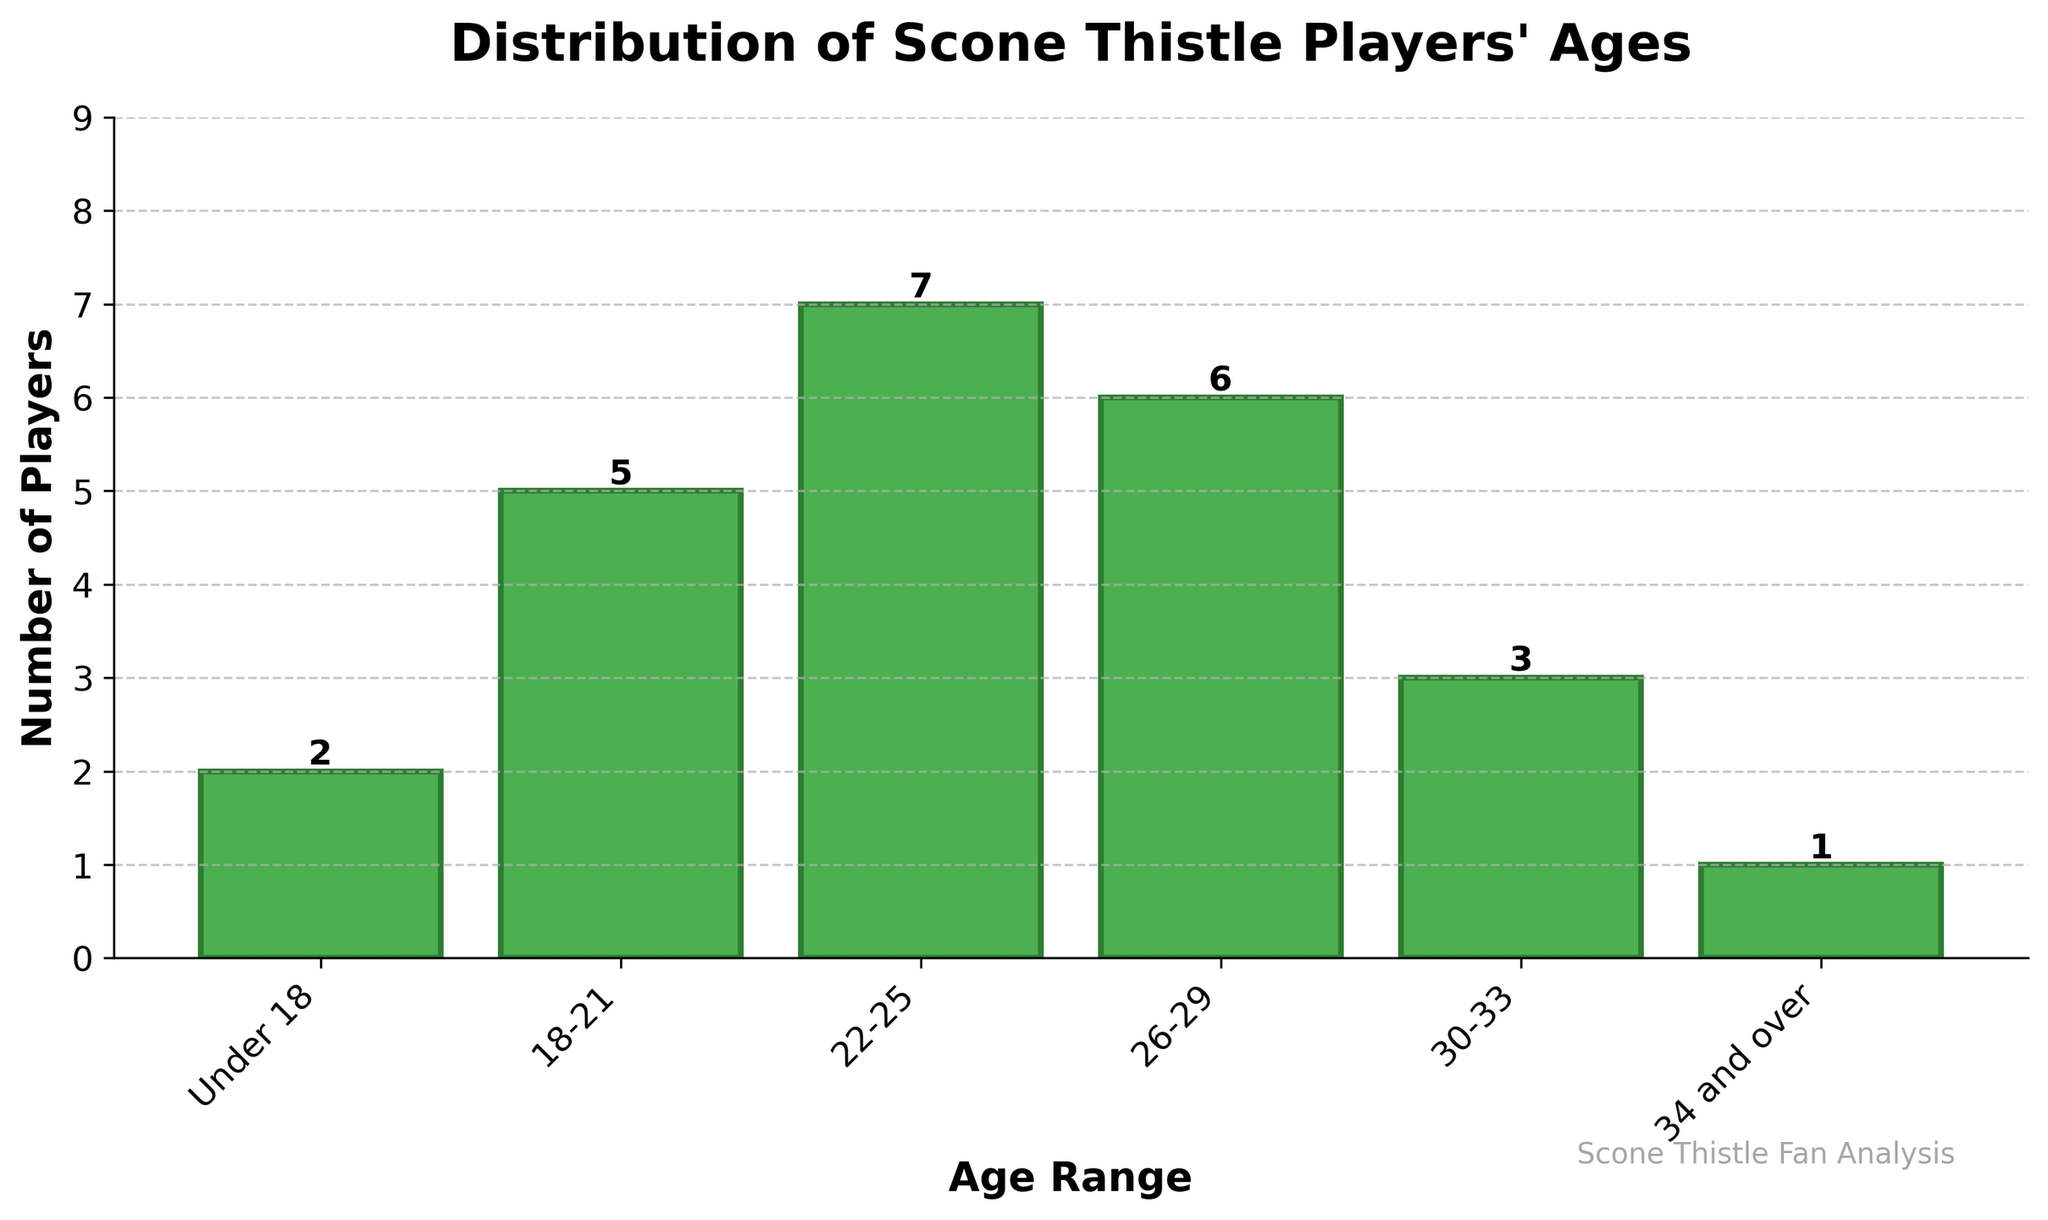What age range has the highest number of Scone Thistle players? The age range with the highest bar represents the highest number of players. The 22-25 age range has the tallest bar with a height of 7.
Answer: 22-25 How many players are in the 30-33 age range compared to the 34 and over age range? The bar for the 30-33 age range has a height of 3, while the bar for the 34 and over age range has a height of 1. Subtract the latter from the former: 3 - 1 = 2.
Answer: 2 more players in 30-33 What's the average number of players across all age ranges? Sum the number of players (2 + 5 + 7 + 6 + 3 + 1) = 24, and then divide by the number of age ranges (6). So, 24 / 6 = 4.
Answer: 4 Which age group has fewer players—Under 18 or 30-33? Compare the heights of the Under 18 bar (2) and the 30-33 bar (3). The Under 18 bar is shorter.
Answer: Under 18 How many players are present in the age ranges between 18 to 25? Sum the number of players in the 18-21 age range (5) and the 22-25 age range (7): 5 + 7 = 12.
Answer: 12 What is the total number of players above 30 years old? Add the number of players in the 30-33 age range (3) and the 34 and over age range (1): 3 + 1 = 4.
Answer: 4 Is the number of players aged 18-21 greater than the number of players aged 26-29? Compare the heights of the bars: 18-21 has 5 players and 26-29 has 6 players. 5 is less than 6.
Answer: No What is the total number of players who are 22 years old or older? Add the number of players in the 22-25 (7), 26-29 (6), 30-33 (3), and 34 and over (1) age ranges: 7 + 6 + 3 + 1 = 17.
Answer: 17 How many more players are there in the 22-25 age range than in the 26-29 age range? The 22-25 age range has 7 players and the 26-29 age range has 6 players. Subtract the latter from the former: 7 - 6 = 1.
Answer: 1 What’s the difference in the number of players between the oldest and youngest age groups? The oldest age group (34 and over) has 1 player, and the youngest age group (Under 18) has 2 players. Subtract the oldest from the youngest: 2 - 1 = 1.
Answer: 1 